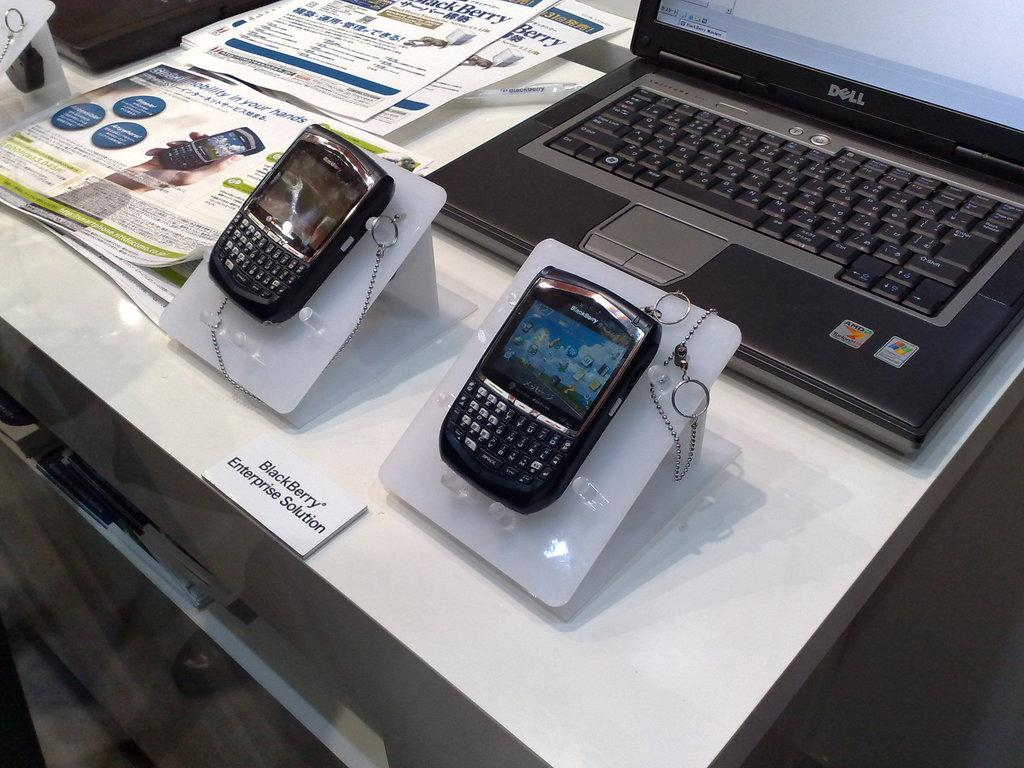Provide a one-sentence caption for the provided image. Two BlackBerry phones sit on display at the BlackBerry Enterprise Solution desk. 